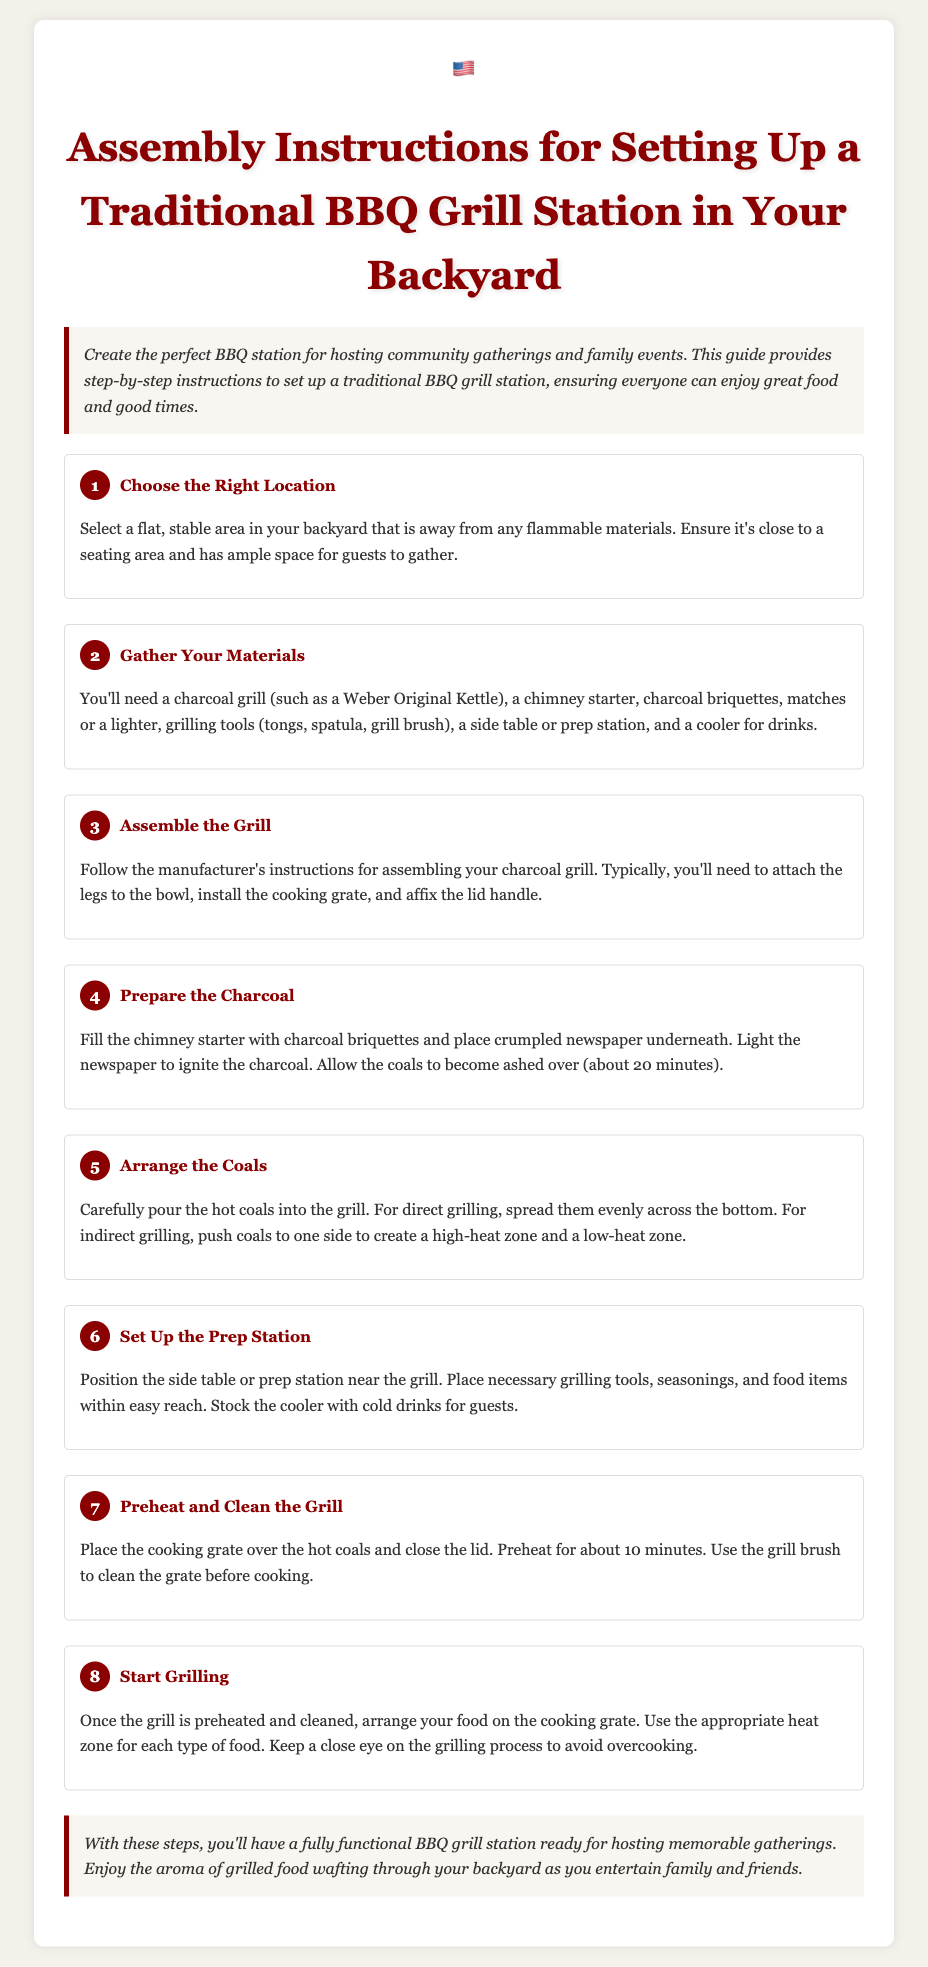What is the first step in setting up the BBQ grill station? The first step is to choose a flat, stable area in your backyard that is away from any flammable materials.
Answer: Choose the Right Location What materials do you need for the BBQ? The document lists materials like a charcoal grill, chimney starter, charcoal briquettes, matches or lighter, grilling tools, side table or prep station, and cooler for drinks.
Answer: Charcoal grill, chimney starter, charcoal briquettes, matches, grilling tools, side table, cooler How long should you allow the coals to become ashed over? The instructions indicate it takes about 20 minutes for the coals to become ashed over.
Answer: 20 minutes What should you do to the cooking grate before cooking? Before cooking, you should use the grill brush to clean the grate after preheating it.
Answer: Clean the grate What is the purpose of a side table or prep station? The purpose is to position it near the grill for easy access to grilling tools, seasonings, and food items.
Answer: Easy access to tools and food What is the recommended height adjustment for food on the grill? The instructions refer to using appropriate heat zones for cooking different types of food.
Answer: Heat zones How many steps are included in the assembly instructions? The document outlines a total of eight steps for setting up the BBQ grill station.
Answer: Eight steps What is the final step in the BBQ grill station assembly? The final step is to start grilling after preheating and cleaning the grill.
Answer: Start Grilling 